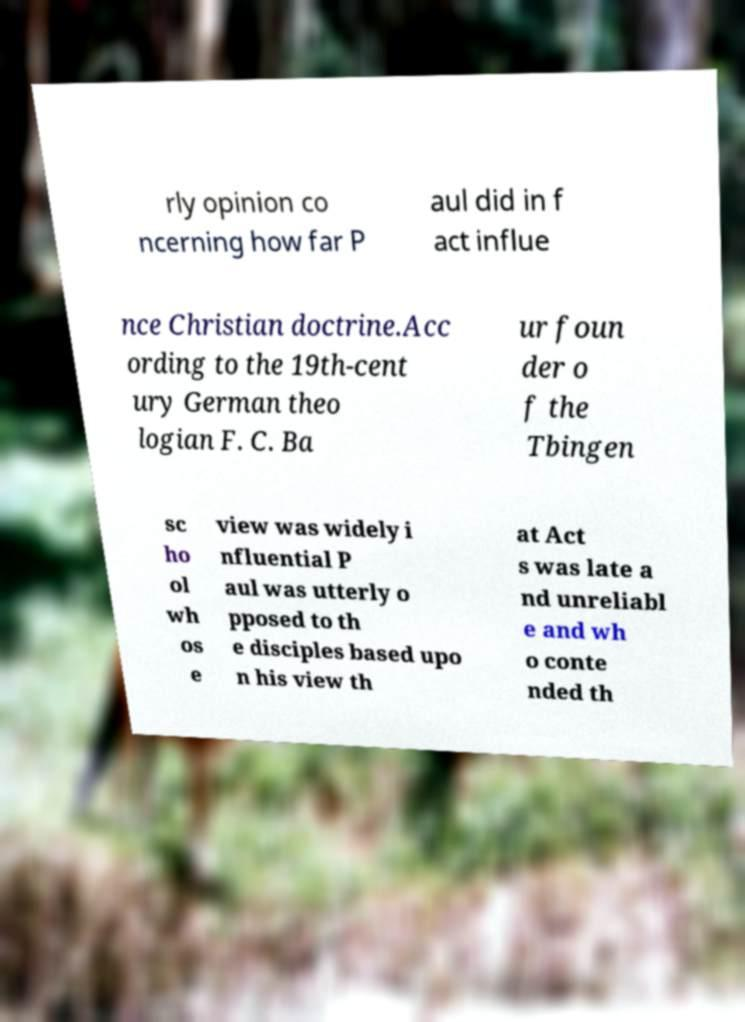Please identify and transcribe the text found in this image. rly opinion co ncerning how far P aul did in f act influe nce Christian doctrine.Acc ording to the 19th-cent ury German theo logian F. C. Ba ur foun der o f the Tbingen sc ho ol wh os e view was widely i nfluential P aul was utterly o pposed to th e disciples based upo n his view th at Act s was late a nd unreliabl e and wh o conte nded th 